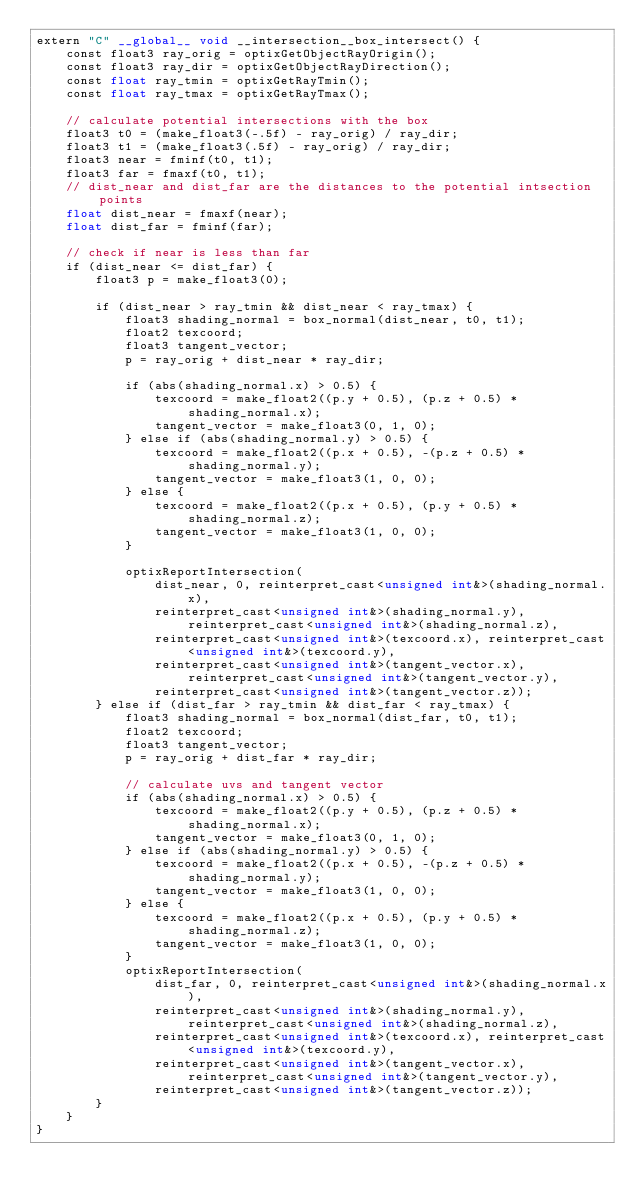<code> <loc_0><loc_0><loc_500><loc_500><_Cuda_>extern "C" __global__ void __intersection__box_intersect() {
    const float3 ray_orig = optixGetObjectRayOrigin();
    const float3 ray_dir = optixGetObjectRayDirection();
    const float ray_tmin = optixGetRayTmin();
    const float ray_tmax = optixGetRayTmax();

    // calculate potential intersections with the box
    float3 t0 = (make_float3(-.5f) - ray_orig) / ray_dir;
    float3 t1 = (make_float3(.5f) - ray_orig) / ray_dir;
    float3 near = fminf(t0, t1);
    float3 far = fmaxf(t0, t1);
    // dist_near and dist_far are the distances to the potential intsection points
    float dist_near = fmaxf(near);
    float dist_far = fminf(far);

    // check if near is less than far
    if (dist_near <= dist_far) {
        float3 p = make_float3(0);

        if (dist_near > ray_tmin && dist_near < ray_tmax) {
            float3 shading_normal = box_normal(dist_near, t0, t1);
            float2 texcoord;
            float3 tangent_vector;
            p = ray_orig + dist_near * ray_dir;

            if (abs(shading_normal.x) > 0.5) {
                texcoord = make_float2((p.y + 0.5), (p.z + 0.5) * shading_normal.x);
                tangent_vector = make_float3(0, 1, 0);
            } else if (abs(shading_normal.y) > 0.5) {
                texcoord = make_float2((p.x + 0.5), -(p.z + 0.5) * shading_normal.y);
                tangent_vector = make_float3(1, 0, 0);
            } else {
                texcoord = make_float2((p.x + 0.5), (p.y + 0.5) * shading_normal.z);
                tangent_vector = make_float3(1, 0, 0);
            }

            optixReportIntersection(
                dist_near, 0, reinterpret_cast<unsigned int&>(shading_normal.x),
                reinterpret_cast<unsigned int&>(shading_normal.y), reinterpret_cast<unsigned int&>(shading_normal.z),
                reinterpret_cast<unsigned int&>(texcoord.x), reinterpret_cast<unsigned int&>(texcoord.y),
                reinterpret_cast<unsigned int&>(tangent_vector.x), reinterpret_cast<unsigned int&>(tangent_vector.y),
                reinterpret_cast<unsigned int&>(tangent_vector.z));
        } else if (dist_far > ray_tmin && dist_far < ray_tmax) {
            float3 shading_normal = box_normal(dist_far, t0, t1);
            float2 texcoord;
            float3 tangent_vector;
            p = ray_orig + dist_far * ray_dir;

            // calculate uvs and tangent vector
            if (abs(shading_normal.x) > 0.5) {
                texcoord = make_float2((p.y + 0.5), (p.z + 0.5) * shading_normal.x);
                tangent_vector = make_float3(0, 1, 0);
            } else if (abs(shading_normal.y) > 0.5) {
                texcoord = make_float2((p.x + 0.5), -(p.z + 0.5) * shading_normal.y);
                tangent_vector = make_float3(1, 0, 0);
            } else {
                texcoord = make_float2((p.x + 0.5), (p.y + 0.5) * shading_normal.z);
                tangent_vector = make_float3(1, 0, 0);
            }
            optixReportIntersection(
                dist_far, 0, reinterpret_cast<unsigned int&>(shading_normal.x),
                reinterpret_cast<unsigned int&>(shading_normal.y), reinterpret_cast<unsigned int&>(shading_normal.z),
                reinterpret_cast<unsigned int&>(texcoord.x), reinterpret_cast<unsigned int&>(texcoord.y),
                reinterpret_cast<unsigned int&>(tangent_vector.x), reinterpret_cast<unsigned int&>(tangent_vector.y),
                reinterpret_cast<unsigned int&>(tangent_vector.z));
        }
    }
}
</code> 